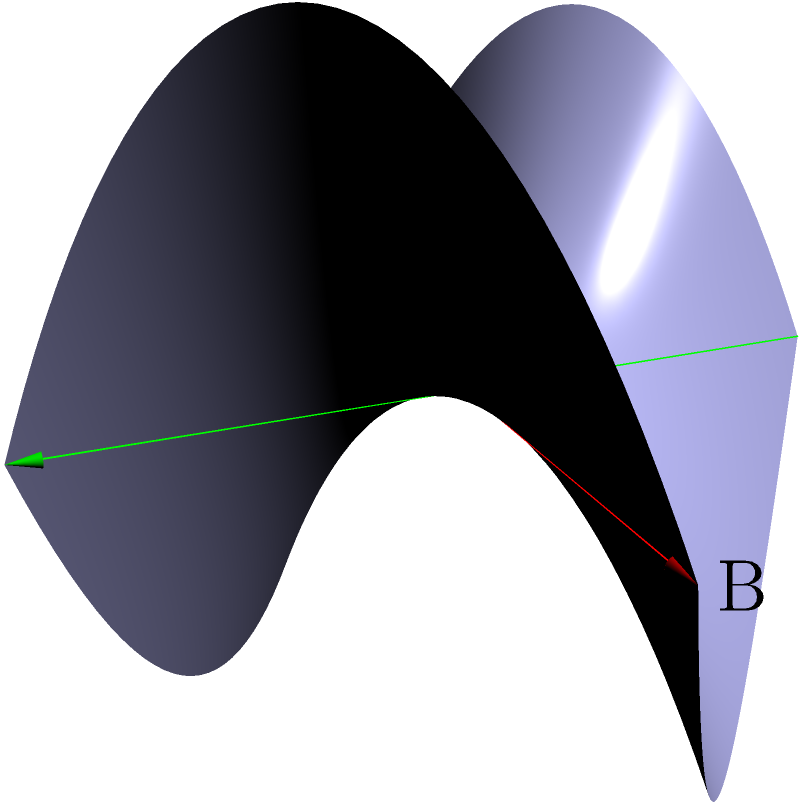Consider a saddle-shaped terrain, reminiscent of certain lizard habitats you've encountered in your fieldwork. On this non-Euclidean surface, represented by the equation $z = x^2 - y^2$, what is the nature of the shortest path between two points A(-2, -2, 0) and B(2, 2, 0)? How does this compare to the straight line path on a flat surface? To understand the shortest path on this saddle-shaped surface, let's follow these steps:

1) In Euclidean geometry, the shortest path between two points is a straight line. However, on a curved surface like this saddle, the shortest path is a geodesic.

2) The surface is described by $z = x^2 - y^2$, which is a hyperbolic paraboloid.

3) For this particular surface:
   a) The red line in the diagram represents the straight line path between A and B in the xy-plane.
   b) The green line represents another possible path on the xy-plane.

4) On this saddle surface:
   a) The straight line (red) actually curves upward, following the surface's shape.
   b) The curved path (green) follows a valley in the surface.

5) The geodesic (shortest path) on this surface will be a curve that balances between:
   a) Minimizing distance in the xy-plane
   b) Minimizing the up-and-down travel along the z-axis

6) In this case, the geodesic will curve slightly away from the straight line, tending towards the valley of the saddle.

7) This geodesic path will be shorter than both:
   a) The path following the straight line in the xy-plane (which curves up significantly on the surface)
   b) The path following the valley exactly (which is longer in the xy-plane)

8) Compared to a flat surface, where the shortest path would be the straight line, this geodesic path on the saddle surface will be longer in absolute distance but shorter than any other path on this curved surface.
Answer: A curved geodesic path, slightly deviating from the straight line towards the saddle's valley, longer than a straight line on a flat surface but shortest on this curved terrain. 